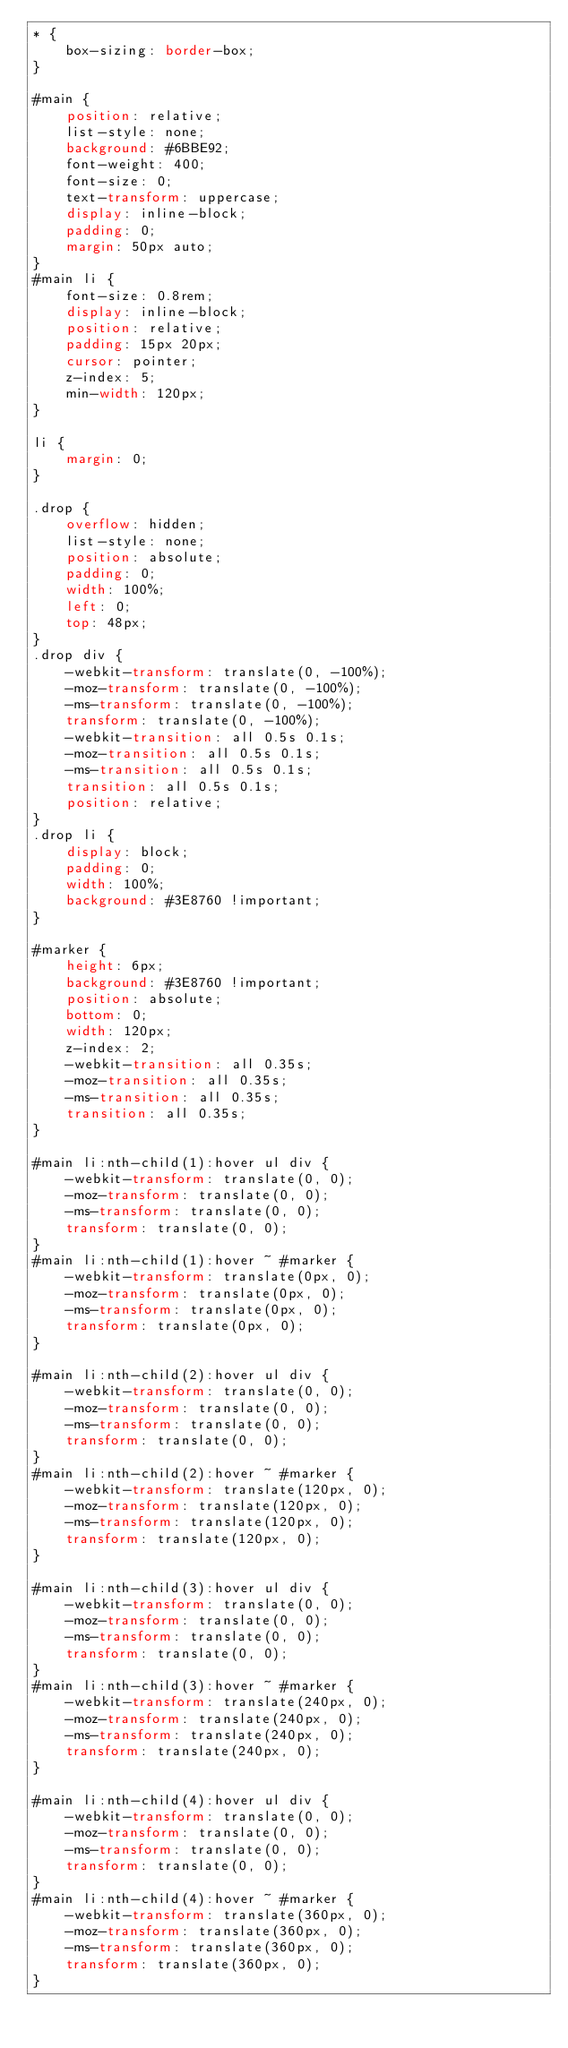Convert code to text. <code><loc_0><loc_0><loc_500><loc_500><_CSS_>* {
    box-sizing: border-box;
}

#main {
    position: relative;
    list-style: none;
    background: #6BBE92;
    font-weight: 400;
    font-size: 0;
    text-transform: uppercase;
    display: inline-block;
    padding: 0;
    margin: 50px auto;
}
#main li {
    font-size: 0.8rem;
    display: inline-block;
    position: relative;
    padding: 15px 20px;
    cursor: pointer;
    z-index: 5;
    min-width: 120px;
}

li {
    margin: 0;
}

.drop {
    overflow: hidden;
    list-style: none;
    position: absolute;
    padding: 0;
    width: 100%;
    left: 0;
    top: 48px;
}
.drop div {
    -webkit-transform: translate(0, -100%);
    -moz-transform: translate(0, -100%);
    -ms-transform: translate(0, -100%);
    transform: translate(0, -100%);
    -webkit-transition: all 0.5s 0.1s;
    -moz-transition: all 0.5s 0.1s;
    -ms-transition: all 0.5s 0.1s;
    transition: all 0.5s 0.1s;
    position: relative;
}
.drop li {
    display: block;
    padding: 0;
    width: 100%;
    background: #3E8760 !important;
}

#marker {
    height: 6px;
    background: #3E8760 !important;
    position: absolute;
    bottom: 0;
    width: 120px;
    z-index: 2;
    -webkit-transition: all 0.35s;
    -moz-transition: all 0.35s;
    -ms-transition: all 0.35s;
    transition: all 0.35s;
}

#main li:nth-child(1):hover ul div {
    -webkit-transform: translate(0, 0);
    -moz-transform: translate(0, 0);
    -ms-transform: translate(0, 0);
    transform: translate(0, 0);
}
#main li:nth-child(1):hover ~ #marker {
    -webkit-transform: translate(0px, 0);
    -moz-transform: translate(0px, 0);
    -ms-transform: translate(0px, 0);
    transform: translate(0px, 0);
}

#main li:nth-child(2):hover ul div {
    -webkit-transform: translate(0, 0);
    -moz-transform: translate(0, 0);
    -ms-transform: translate(0, 0);
    transform: translate(0, 0);
}
#main li:nth-child(2):hover ~ #marker {
    -webkit-transform: translate(120px, 0);
    -moz-transform: translate(120px, 0);
    -ms-transform: translate(120px, 0);
    transform: translate(120px, 0);
}

#main li:nth-child(3):hover ul div {
    -webkit-transform: translate(0, 0);
    -moz-transform: translate(0, 0);
    -ms-transform: translate(0, 0);
    transform: translate(0, 0);
}
#main li:nth-child(3):hover ~ #marker {
    -webkit-transform: translate(240px, 0);
    -moz-transform: translate(240px, 0);
    -ms-transform: translate(240px, 0);
    transform: translate(240px, 0);
}

#main li:nth-child(4):hover ul div {
    -webkit-transform: translate(0, 0);
    -moz-transform: translate(0, 0);
    -ms-transform: translate(0, 0);
    transform: translate(0, 0);
}
#main li:nth-child(4):hover ~ #marker {
    -webkit-transform: translate(360px, 0);
    -moz-transform: translate(360px, 0);
    -ms-transform: translate(360px, 0);
    transform: translate(360px, 0);
}
</code> 